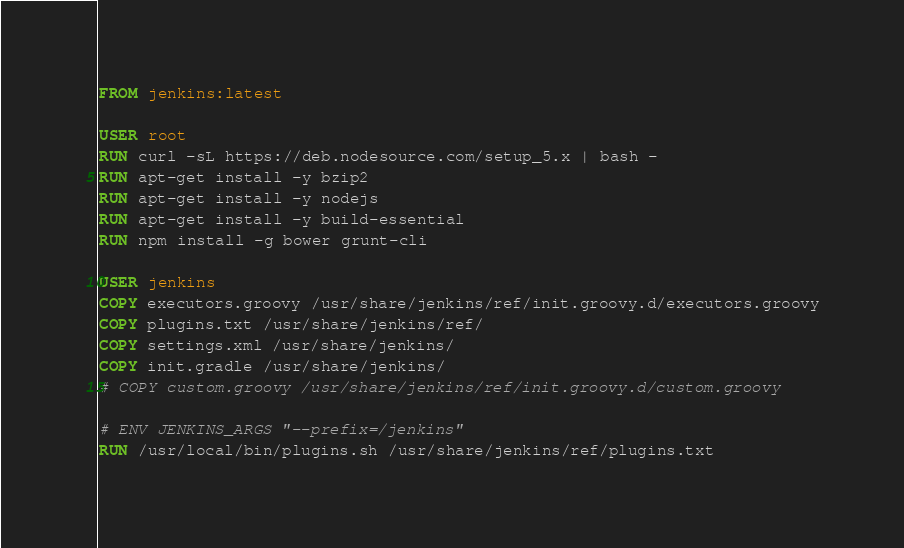<code> <loc_0><loc_0><loc_500><loc_500><_Dockerfile_>FROM jenkins:latest

USER root
RUN curl -sL https://deb.nodesource.com/setup_5.x | bash -
RUN apt-get install -y bzip2
RUN apt-get install -y nodejs
RUN apt-get install -y build-essential
RUN npm install -g bower grunt-cli

USER jenkins
COPY executors.groovy /usr/share/jenkins/ref/init.groovy.d/executors.groovy
COPY plugins.txt /usr/share/jenkins/ref/
COPY settings.xml /usr/share/jenkins/
COPY init.gradle /usr/share/jenkins/
# COPY custom.groovy /usr/share/jenkins/ref/init.groovy.d/custom.groovy

# ENV JENKINS_ARGS "--prefix=/jenkins"
RUN /usr/local/bin/plugins.sh /usr/share/jenkins/ref/plugins.txt
</code> 